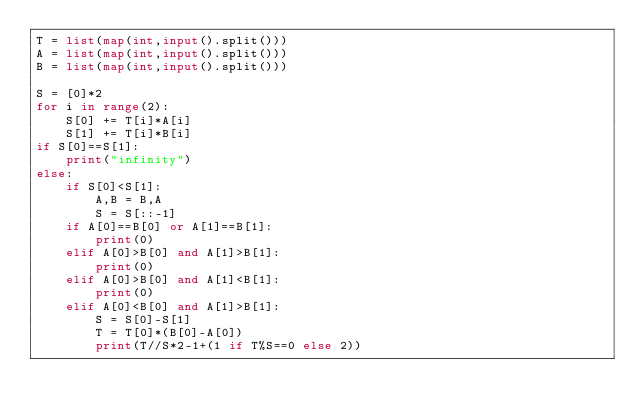<code> <loc_0><loc_0><loc_500><loc_500><_Python_>T = list(map(int,input().split()))
A = list(map(int,input().split()))
B = list(map(int,input().split()))

S = [0]*2
for i in range(2):
    S[0] += T[i]*A[i]
    S[1] += T[i]*B[i]
if S[0]==S[1]:
    print("infinity")
else:
    if S[0]<S[1]:
        A,B = B,A
        S = S[::-1]
    if A[0]==B[0] or A[1]==B[1]:
        print(0)
    elif A[0]>B[0] and A[1]>B[1]:
        print(0)
    elif A[0]>B[0] and A[1]<B[1]:
        print(0)
    elif A[0]<B[0] and A[1]>B[1]:
        S = S[0]-S[1]
        T = T[0]*(B[0]-A[0])
        print(T//S*2-1+(1 if T%S==0 else 2))</code> 